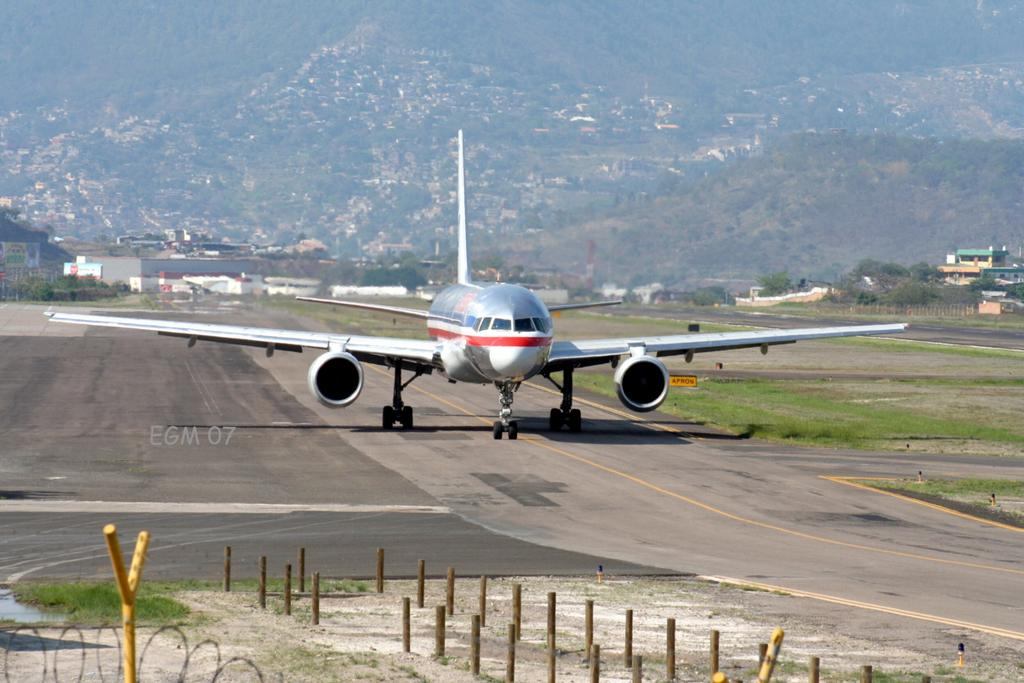What is the unusual object on the road in the image? There is an airplane on the road in the image. What type of structures can be seen in the image? There are poles, buildings, and a mountain visible in the image. What type of vegetation is present in the image? Grass and trees are visible in the image. What type of cable is being used to connect the airplane to the mountain in the image? There is no cable connecting the airplane to the mountain in the image. 